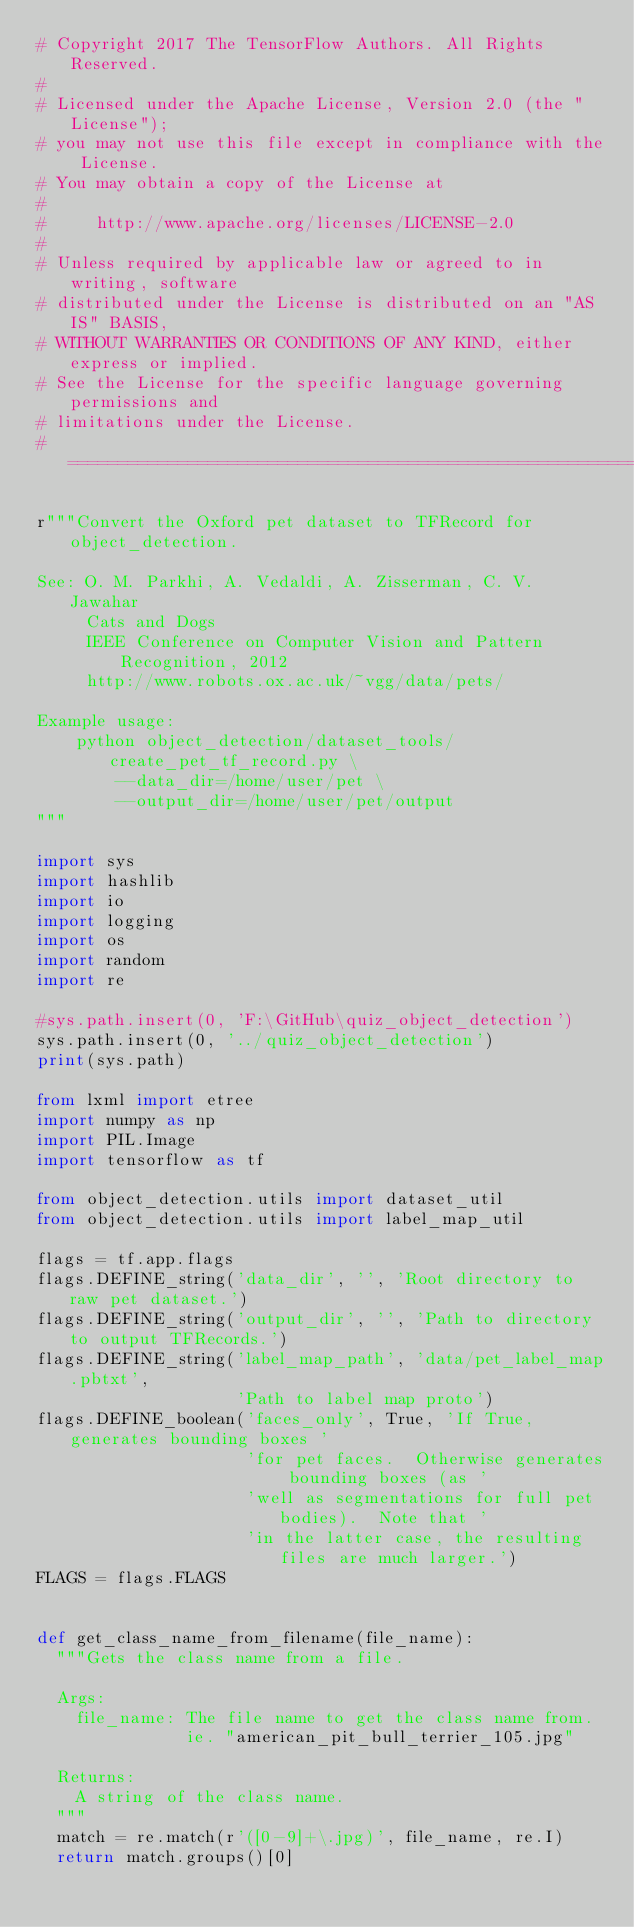Convert code to text. <code><loc_0><loc_0><loc_500><loc_500><_Python_># Copyright 2017 The TensorFlow Authors. All Rights Reserved.
#
# Licensed under the Apache License, Version 2.0 (the "License");
# you may not use this file except in compliance with the License.
# You may obtain a copy of the License at
#
#     http://www.apache.org/licenses/LICENSE-2.0
#
# Unless required by applicable law or agreed to in writing, software
# distributed under the License is distributed on an "AS IS" BASIS,
# WITHOUT WARRANTIES OR CONDITIONS OF ANY KIND, either express or implied.
# See the License for the specific language governing permissions and
# limitations under the License.
# ==============================================================================

r"""Convert the Oxford pet dataset to TFRecord for object_detection.

See: O. M. Parkhi, A. Vedaldi, A. Zisserman, C. V. Jawahar
     Cats and Dogs
     IEEE Conference on Computer Vision and Pattern Recognition, 2012
     http://www.robots.ox.ac.uk/~vgg/data/pets/

Example usage:
    python object_detection/dataset_tools/create_pet_tf_record.py \
        --data_dir=/home/user/pet \
        --output_dir=/home/user/pet/output
"""

import sys
import hashlib
import io
import logging
import os
import random
import re

#sys.path.insert(0, 'F:\GitHub\quiz_object_detection')
sys.path.insert(0, '../quiz_object_detection')
print(sys.path)

from lxml import etree
import numpy as np
import PIL.Image
import tensorflow as tf

from object_detection.utils import dataset_util
from object_detection.utils import label_map_util

flags = tf.app.flags
flags.DEFINE_string('data_dir', '', 'Root directory to raw pet dataset.')
flags.DEFINE_string('output_dir', '', 'Path to directory to output TFRecords.')
flags.DEFINE_string('label_map_path', 'data/pet_label_map.pbtxt',
                    'Path to label map proto')
flags.DEFINE_boolean('faces_only', True, 'If True, generates bounding boxes '
                     'for pet faces.  Otherwise generates bounding boxes (as '
                     'well as segmentations for full pet bodies).  Note that '
                     'in the latter case, the resulting files are much larger.')
FLAGS = flags.FLAGS


def get_class_name_from_filename(file_name):
  """Gets the class name from a file.

  Args:
    file_name: The file name to get the class name from.
               ie. "american_pit_bull_terrier_105.jpg"

  Returns:
    A string of the class name.
  """
  match = re.match(r'([0-9]+\.jpg)', file_name, re.I)
  return match.groups()[0]

</code> 